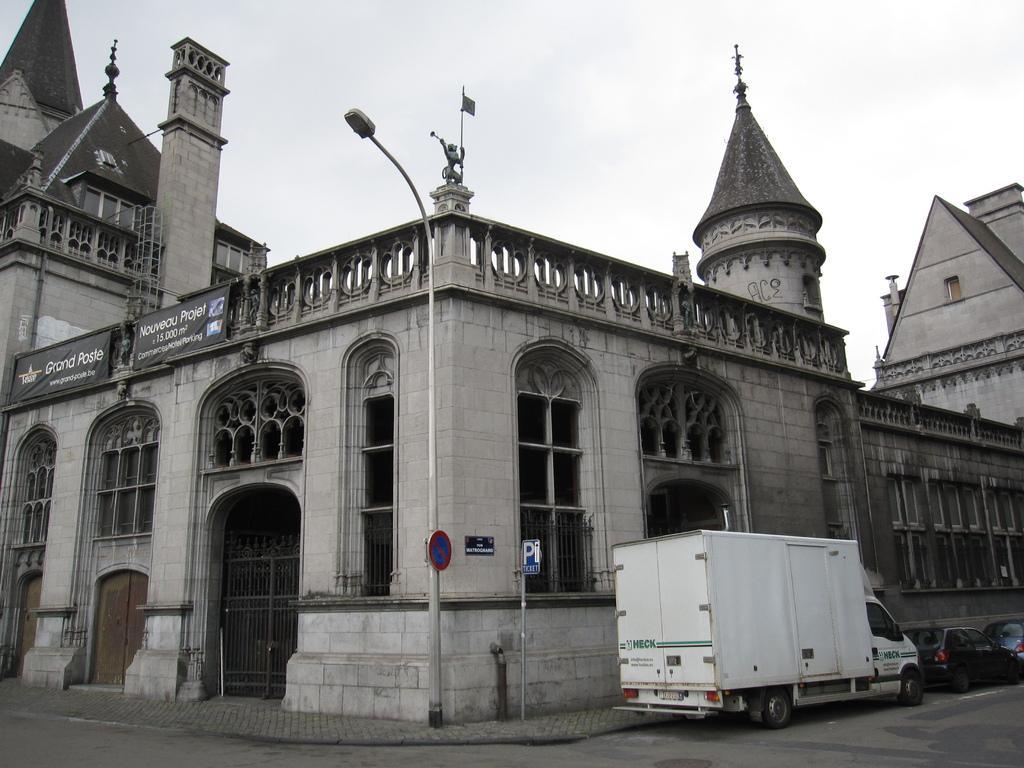Can you describe this image briefly? In this image in the center there are some buildings, poles, lights, and some boards. On the left side of the building, there are some boards on the building and there is pole, flag and some statue in the center. At the bottom there is road and on the road there are some vehicles, and at the top there is sky. 